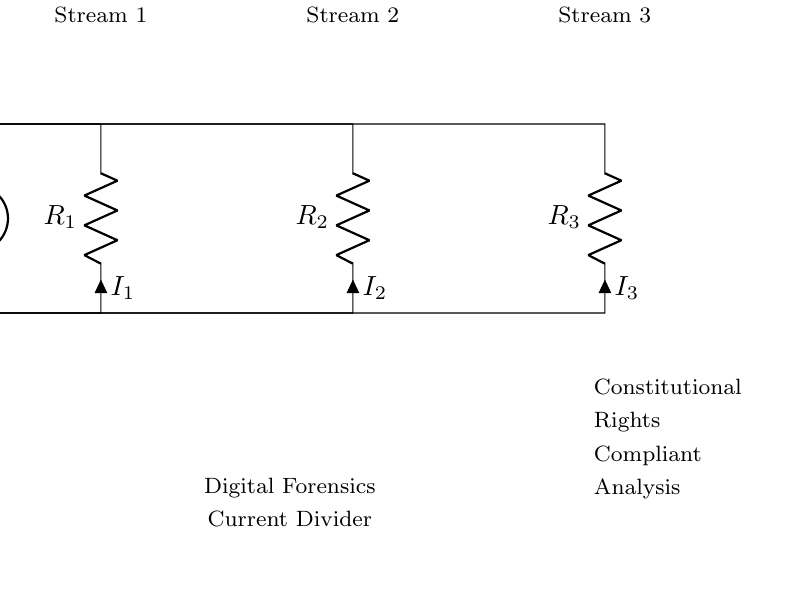What is the total current entering the circuit? The total current is denoted as **I total** in the circuit. It flows into the circuit from the current source at the top.
Answer: I total What is one of the resistors in the circuit? The circuit contains three resistors: **R1**, **R2**, and **R3**. Each is connected in parallel.
Answer: R1 How many data streams are analyzed in the setup? The circuit diagram shows three distinct outputs for data streams, indicating three separate analyses occurring simultaneously.
Answer: 3 Which resistor experiences the highest current in a current divider? In a current divider, the current through each resistor is inversely proportional to its resistance. The resistor with the smallest value would have the highest current, depending on their actual values.
Answer: R1 (if its value is less than R2 and R3) What is the role of the current divider in this setup? The current divider's role in this context is to split the total current into multiple paths, allowing for simultaneous analysis of different data streams without interfering with each other, thus maintaining the integrity of forensics.
Answer: Splitting current What does the label beside the diagram indicate about the analysis? The label states "**Constitutional Rights Compliant Analysis**," which suggests that the analysis performed respects legal standards and upholds individual rights during the digital forensic investigation.
Answer: Constitutional Rights Compliant Analysis 